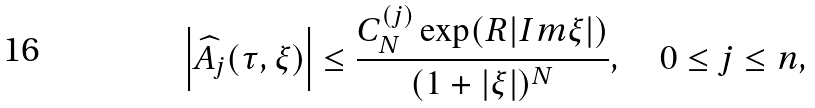<formula> <loc_0><loc_0><loc_500><loc_500>\left | \widehat { A _ { j } } ( \tau , \xi ) \right | \leq \frac { C _ { N } ^ { ( j ) } \exp ( R | I m \xi | ) } { ( 1 + | \xi | ) ^ { N } } , \quad 0 \leq j \leq n ,</formula> 